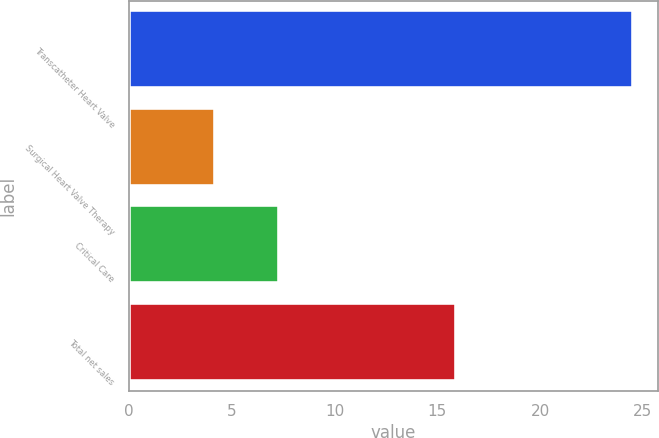Convert chart to OTSL. <chart><loc_0><loc_0><loc_500><loc_500><bar_chart><fcel>Transcatheter Heart Valve<fcel>Surgical Heart Valve Therapy<fcel>Critical Care<fcel>Total net sales<nl><fcel>24.5<fcel>4.2<fcel>7.3<fcel>15.9<nl></chart> 